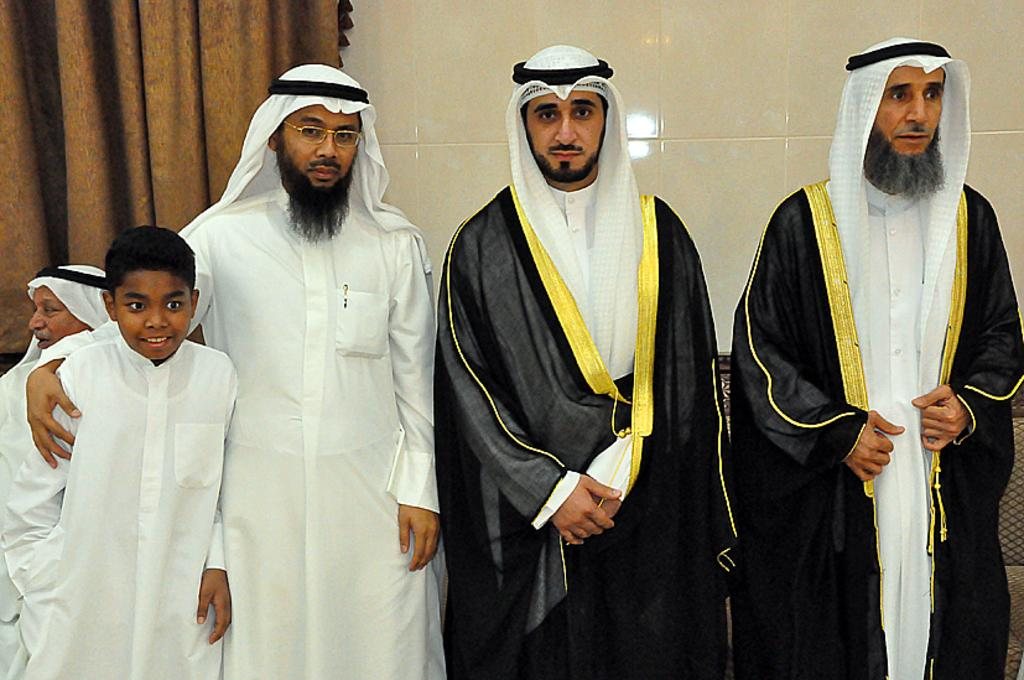How many people are in the foreground of the image? There are three men and a boy in the foreground of the image. What is the relationship between the boy and the men in the foreground? The boy is standing with the men in the foreground. Can you describe the background of the image? There is a man, a curtain, and a wall in the background of the image. What type of nerve can be seen in the image? There is no nerve present in the image. Is there a bucket visible in the image? There is no bucket present in the image. 